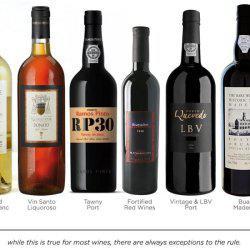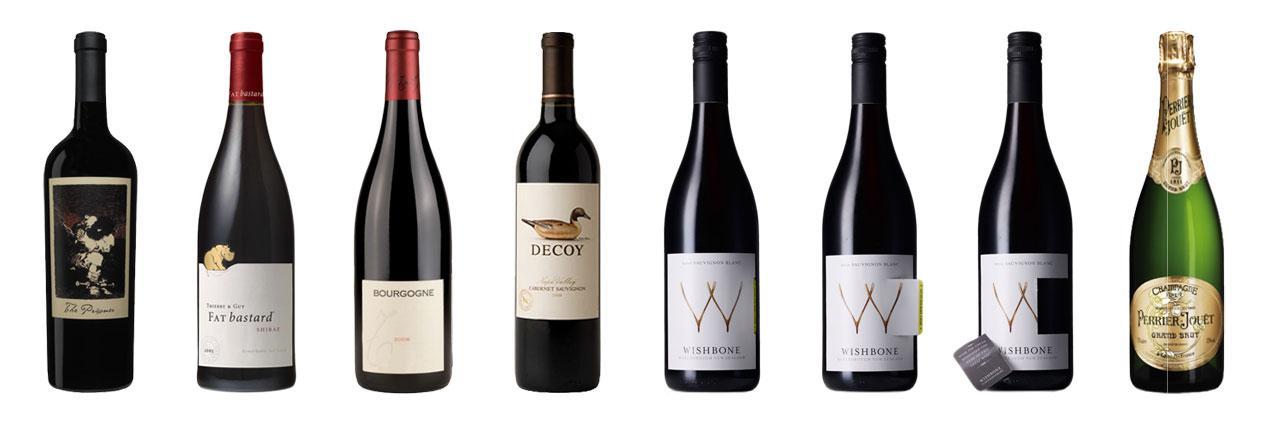The first image is the image on the left, the second image is the image on the right. Considering the images on both sides, is "Seven different unopened bottles of wine are lined up in each image." valid? Answer yes or no. No. 